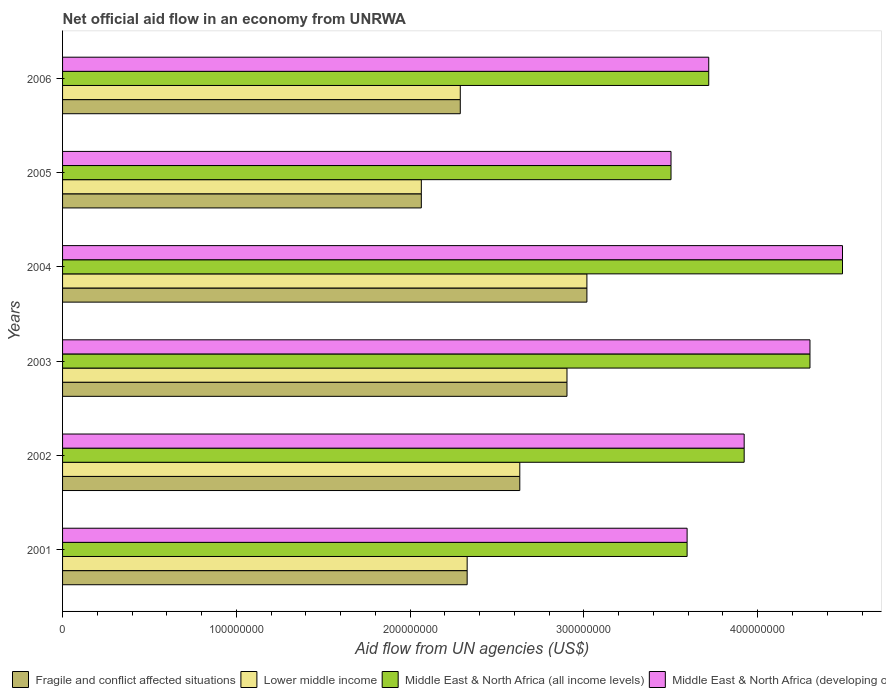How many different coloured bars are there?
Make the answer very short. 4. How many groups of bars are there?
Your answer should be very brief. 6. How many bars are there on the 5th tick from the bottom?
Keep it short and to the point. 4. In how many cases, is the number of bars for a given year not equal to the number of legend labels?
Make the answer very short. 0. What is the net official aid flow in Fragile and conflict affected situations in 2003?
Ensure brevity in your answer.  2.90e+08. Across all years, what is the maximum net official aid flow in Middle East & North Africa (developing only)?
Offer a terse response. 4.49e+08. Across all years, what is the minimum net official aid flow in Middle East & North Africa (all income levels)?
Make the answer very short. 3.50e+08. In which year was the net official aid flow in Middle East & North Africa (developing only) maximum?
Offer a very short reply. 2004. What is the total net official aid flow in Middle East & North Africa (all income levels) in the graph?
Offer a terse response. 2.35e+09. What is the difference between the net official aid flow in Fragile and conflict affected situations in 2004 and that in 2005?
Make the answer very short. 9.53e+07. What is the difference between the net official aid flow in Lower middle income in 2004 and the net official aid flow in Fragile and conflict affected situations in 2001?
Keep it short and to the point. 6.89e+07. What is the average net official aid flow in Middle East & North Africa (developing only) per year?
Your answer should be very brief. 3.92e+08. In the year 2006, what is the difference between the net official aid flow in Middle East & North Africa (developing only) and net official aid flow in Middle East & North Africa (all income levels)?
Offer a terse response. 0. What is the ratio of the net official aid flow in Middle East & North Africa (all income levels) in 2003 to that in 2005?
Your response must be concise. 1.23. What is the difference between the highest and the second highest net official aid flow in Fragile and conflict affected situations?
Give a very brief answer. 1.15e+07. What is the difference between the highest and the lowest net official aid flow in Middle East & North Africa (developing only)?
Provide a succinct answer. 9.87e+07. In how many years, is the net official aid flow in Middle East & North Africa (all income levels) greater than the average net official aid flow in Middle East & North Africa (all income levels) taken over all years?
Keep it short and to the point. 3. Is it the case that in every year, the sum of the net official aid flow in Middle East & North Africa (all income levels) and net official aid flow in Middle East & North Africa (developing only) is greater than the sum of net official aid flow in Fragile and conflict affected situations and net official aid flow in Lower middle income?
Your answer should be compact. No. What does the 1st bar from the top in 2006 represents?
Offer a terse response. Middle East & North Africa (developing only). What does the 2nd bar from the bottom in 2004 represents?
Provide a short and direct response. Lower middle income. Is it the case that in every year, the sum of the net official aid flow in Lower middle income and net official aid flow in Middle East & North Africa (all income levels) is greater than the net official aid flow in Middle East & North Africa (developing only)?
Offer a very short reply. Yes. Are all the bars in the graph horizontal?
Offer a very short reply. Yes. What is the difference between two consecutive major ticks on the X-axis?
Your response must be concise. 1.00e+08. Are the values on the major ticks of X-axis written in scientific E-notation?
Provide a succinct answer. No. Does the graph contain grids?
Offer a very short reply. No. How many legend labels are there?
Ensure brevity in your answer.  4. What is the title of the graph?
Provide a succinct answer. Net official aid flow in an economy from UNRWA. What is the label or title of the X-axis?
Make the answer very short. Aid flow from UN agencies (US$). What is the label or title of the Y-axis?
Your answer should be compact. Years. What is the Aid flow from UN agencies (US$) in Fragile and conflict affected situations in 2001?
Provide a succinct answer. 2.33e+08. What is the Aid flow from UN agencies (US$) of Lower middle income in 2001?
Offer a terse response. 2.33e+08. What is the Aid flow from UN agencies (US$) of Middle East & North Africa (all income levels) in 2001?
Keep it short and to the point. 3.59e+08. What is the Aid flow from UN agencies (US$) in Middle East & North Africa (developing only) in 2001?
Keep it short and to the point. 3.59e+08. What is the Aid flow from UN agencies (US$) in Fragile and conflict affected situations in 2002?
Offer a terse response. 2.63e+08. What is the Aid flow from UN agencies (US$) of Lower middle income in 2002?
Your response must be concise. 2.63e+08. What is the Aid flow from UN agencies (US$) of Middle East & North Africa (all income levels) in 2002?
Make the answer very short. 3.92e+08. What is the Aid flow from UN agencies (US$) of Middle East & North Africa (developing only) in 2002?
Give a very brief answer. 3.92e+08. What is the Aid flow from UN agencies (US$) of Fragile and conflict affected situations in 2003?
Provide a succinct answer. 2.90e+08. What is the Aid flow from UN agencies (US$) in Lower middle income in 2003?
Provide a succinct answer. 2.90e+08. What is the Aid flow from UN agencies (US$) of Middle East & North Africa (all income levels) in 2003?
Make the answer very short. 4.30e+08. What is the Aid flow from UN agencies (US$) of Middle East & North Africa (developing only) in 2003?
Make the answer very short. 4.30e+08. What is the Aid flow from UN agencies (US$) in Fragile and conflict affected situations in 2004?
Ensure brevity in your answer.  3.02e+08. What is the Aid flow from UN agencies (US$) in Lower middle income in 2004?
Offer a terse response. 3.02e+08. What is the Aid flow from UN agencies (US$) of Middle East & North Africa (all income levels) in 2004?
Your answer should be very brief. 4.49e+08. What is the Aid flow from UN agencies (US$) in Middle East & North Africa (developing only) in 2004?
Ensure brevity in your answer.  4.49e+08. What is the Aid flow from UN agencies (US$) in Fragile and conflict affected situations in 2005?
Your answer should be very brief. 2.06e+08. What is the Aid flow from UN agencies (US$) in Lower middle income in 2005?
Provide a short and direct response. 2.06e+08. What is the Aid flow from UN agencies (US$) in Middle East & North Africa (all income levels) in 2005?
Ensure brevity in your answer.  3.50e+08. What is the Aid flow from UN agencies (US$) in Middle East & North Africa (developing only) in 2005?
Your response must be concise. 3.50e+08. What is the Aid flow from UN agencies (US$) of Fragile and conflict affected situations in 2006?
Your answer should be compact. 2.29e+08. What is the Aid flow from UN agencies (US$) of Lower middle income in 2006?
Keep it short and to the point. 2.29e+08. What is the Aid flow from UN agencies (US$) in Middle East & North Africa (all income levels) in 2006?
Ensure brevity in your answer.  3.72e+08. What is the Aid flow from UN agencies (US$) in Middle East & North Africa (developing only) in 2006?
Provide a succinct answer. 3.72e+08. Across all years, what is the maximum Aid flow from UN agencies (US$) in Fragile and conflict affected situations?
Give a very brief answer. 3.02e+08. Across all years, what is the maximum Aid flow from UN agencies (US$) of Lower middle income?
Your response must be concise. 3.02e+08. Across all years, what is the maximum Aid flow from UN agencies (US$) of Middle East & North Africa (all income levels)?
Ensure brevity in your answer.  4.49e+08. Across all years, what is the maximum Aid flow from UN agencies (US$) of Middle East & North Africa (developing only)?
Ensure brevity in your answer.  4.49e+08. Across all years, what is the minimum Aid flow from UN agencies (US$) in Fragile and conflict affected situations?
Provide a short and direct response. 2.06e+08. Across all years, what is the minimum Aid flow from UN agencies (US$) in Lower middle income?
Your answer should be very brief. 2.06e+08. Across all years, what is the minimum Aid flow from UN agencies (US$) in Middle East & North Africa (all income levels)?
Keep it short and to the point. 3.50e+08. Across all years, what is the minimum Aid flow from UN agencies (US$) of Middle East & North Africa (developing only)?
Make the answer very short. 3.50e+08. What is the total Aid flow from UN agencies (US$) of Fragile and conflict affected situations in the graph?
Provide a succinct answer. 1.52e+09. What is the total Aid flow from UN agencies (US$) in Lower middle income in the graph?
Give a very brief answer. 1.52e+09. What is the total Aid flow from UN agencies (US$) in Middle East & North Africa (all income levels) in the graph?
Keep it short and to the point. 2.35e+09. What is the total Aid flow from UN agencies (US$) in Middle East & North Africa (developing only) in the graph?
Offer a very short reply. 2.35e+09. What is the difference between the Aid flow from UN agencies (US$) of Fragile and conflict affected situations in 2001 and that in 2002?
Your answer should be very brief. -3.03e+07. What is the difference between the Aid flow from UN agencies (US$) of Lower middle income in 2001 and that in 2002?
Make the answer very short. -3.03e+07. What is the difference between the Aid flow from UN agencies (US$) of Middle East & North Africa (all income levels) in 2001 and that in 2002?
Your response must be concise. -3.28e+07. What is the difference between the Aid flow from UN agencies (US$) in Middle East & North Africa (developing only) in 2001 and that in 2002?
Offer a very short reply. -3.28e+07. What is the difference between the Aid flow from UN agencies (US$) of Fragile and conflict affected situations in 2001 and that in 2003?
Provide a succinct answer. -5.74e+07. What is the difference between the Aid flow from UN agencies (US$) of Lower middle income in 2001 and that in 2003?
Offer a terse response. -5.74e+07. What is the difference between the Aid flow from UN agencies (US$) of Middle East & North Africa (all income levels) in 2001 and that in 2003?
Provide a short and direct response. -7.07e+07. What is the difference between the Aid flow from UN agencies (US$) in Middle East & North Africa (developing only) in 2001 and that in 2003?
Provide a succinct answer. -7.07e+07. What is the difference between the Aid flow from UN agencies (US$) of Fragile and conflict affected situations in 2001 and that in 2004?
Offer a very short reply. -6.89e+07. What is the difference between the Aid flow from UN agencies (US$) of Lower middle income in 2001 and that in 2004?
Ensure brevity in your answer.  -6.89e+07. What is the difference between the Aid flow from UN agencies (US$) of Middle East & North Africa (all income levels) in 2001 and that in 2004?
Make the answer very short. -8.94e+07. What is the difference between the Aid flow from UN agencies (US$) of Middle East & North Africa (developing only) in 2001 and that in 2004?
Your answer should be very brief. -8.94e+07. What is the difference between the Aid flow from UN agencies (US$) of Fragile and conflict affected situations in 2001 and that in 2005?
Provide a succinct answer. 2.64e+07. What is the difference between the Aid flow from UN agencies (US$) in Lower middle income in 2001 and that in 2005?
Make the answer very short. 2.64e+07. What is the difference between the Aid flow from UN agencies (US$) in Middle East & North Africa (all income levels) in 2001 and that in 2005?
Make the answer very short. 9.26e+06. What is the difference between the Aid flow from UN agencies (US$) of Middle East & North Africa (developing only) in 2001 and that in 2005?
Ensure brevity in your answer.  9.26e+06. What is the difference between the Aid flow from UN agencies (US$) of Fragile and conflict affected situations in 2001 and that in 2006?
Keep it short and to the point. 3.96e+06. What is the difference between the Aid flow from UN agencies (US$) of Lower middle income in 2001 and that in 2006?
Your response must be concise. 3.96e+06. What is the difference between the Aid flow from UN agencies (US$) in Middle East & North Africa (all income levels) in 2001 and that in 2006?
Your answer should be compact. -1.24e+07. What is the difference between the Aid flow from UN agencies (US$) of Middle East & North Africa (developing only) in 2001 and that in 2006?
Provide a short and direct response. -1.24e+07. What is the difference between the Aid flow from UN agencies (US$) of Fragile and conflict affected situations in 2002 and that in 2003?
Your answer should be very brief. -2.72e+07. What is the difference between the Aid flow from UN agencies (US$) of Lower middle income in 2002 and that in 2003?
Your answer should be compact. -2.72e+07. What is the difference between the Aid flow from UN agencies (US$) in Middle East & North Africa (all income levels) in 2002 and that in 2003?
Keep it short and to the point. -3.79e+07. What is the difference between the Aid flow from UN agencies (US$) in Middle East & North Africa (developing only) in 2002 and that in 2003?
Your answer should be very brief. -3.79e+07. What is the difference between the Aid flow from UN agencies (US$) in Fragile and conflict affected situations in 2002 and that in 2004?
Make the answer very short. -3.86e+07. What is the difference between the Aid flow from UN agencies (US$) in Lower middle income in 2002 and that in 2004?
Offer a terse response. -3.86e+07. What is the difference between the Aid flow from UN agencies (US$) in Middle East & North Africa (all income levels) in 2002 and that in 2004?
Give a very brief answer. -5.66e+07. What is the difference between the Aid flow from UN agencies (US$) of Middle East & North Africa (developing only) in 2002 and that in 2004?
Give a very brief answer. -5.66e+07. What is the difference between the Aid flow from UN agencies (US$) in Fragile and conflict affected situations in 2002 and that in 2005?
Your answer should be compact. 5.67e+07. What is the difference between the Aid flow from UN agencies (US$) in Lower middle income in 2002 and that in 2005?
Give a very brief answer. 5.67e+07. What is the difference between the Aid flow from UN agencies (US$) in Middle East & North Africa (all income levels) in 2002 and that in 2005?
Provide a short and direct response. 4.21e+07. What is the difference between the Aid flow from UN agencies (US$) in Middle East & North Africa (developing only) in 2002 and that in 2005?
Give a very brief answer. 4.21e+07. What is the difference between the Aid flow from UN agencies (US$) of Fragile and conflict affected situations in 2002 and that in 2006?
Offer a very short reply. 3.42e+07. What is the difference between the Aid flow from UN agencies (US$) of Lower middle income in 2002 and that in 2006?
Your response must be concise. 3.42e+07. What is the difference between the Aid flow from UN agencies (US$) of Middle East & North Africa (all income levels) in 2002 and that in 2006?
Your answer should be compact. 2.04e+07. What is the difference between the Aid flow from UN agencies (US$) in Middle East & North Africa (developing only) in 2002 and that in 2006?
Make the answer very short. 2.04e+07. What is the difference between the Aid flow from UN agencies (US$) of Fragile and conflict affected situations in 2003 and that in 2004?
Offer a very short reply. -1.15e+07. What is the difference between the Aid flow from UN agencies (US$) in Lower middle income in 2003 and that in 2004?
Make the answer very short. -1.15e+07. What is the difference between the Aid flow from UN agencies (US$) of Middle East & North Africa (all income levels) in 2003 and that in 2004?
Provide a short and direct response. -1.87e+07. What is the difference between the Aid flow from UN agencies (US$) of Middle East & North Africa (developing only) in 2003 and that in 2004?
Your answer should be very brief. -1.87e+07. What is the difference between the Aid flow from UN agencies (US$) in Fragile and conflict affected situations in 2003 and that in 2005?
Your response must be concise. 8.38e+07. What is the difference between the Aid flow from UN agencies (US$) of Lower middle income in 2003 and that in 2005?
Your answer should be compact. 8.38e+07. What is the difference between the Aid flow from UN agencies (US$) in Middle East & North Africa (all income levels) in 2003 and that in 2005?
Offer a very short reply. 8.00e+07. What is the difference between the Aid flow from UN agencies (US$) of Middle East & North Africa (developing only) in 2003 and that in 2005?
Your answer should be compact. 8.00e+07. What is the difference between the Aid flow from UN agencies (US$) in Fragile and conflict affected situations in 2003 and that in 2006?
Offer a very short reply. 6.14e+07. What is the difference between the Aid flow from UN agencies (US$) of Lower middle income in 2003 and that in 2006?
Your answer should be compact. 6.14e+07. What is the difference between the Aid flow from UN agencies (US$) of Middle East & North Africa (all income levels) in 2003 and that in 2006?
Offer a terse response. 5.82e+07. What is the difference between the Aid flow from UN agencies (US$) of Middle East & North Africa (developing only) in 2003 and that in 2006?
Ensure brevity in your answer.  5.82e+07. What is the difference between the Aid flow from UN agencies (US$) in Fragile and conflict affected situations in 2004 and that in 2005?
Your answer should be very brief. 9.53e+07. What is the difference between the Aid flow from UN agencies (US$) of Lower middle income in 2004 and that in 2005?
Offer a terse response. 9.53e+07. What is the difference between the Aid flow from UN agencies (US$) of Middle East & North Africa (all income levels) in 2004 and that in 2005?
Your answer should be very brief. 9.87e+07. What is the difference between the Aid flow from UN agencies (US$) of Middle East & North Africa (developing only) in 2004 and that in 2005?
Provide a short and direct response. 9.87e+07. What is the difference between the Aid flow from UN agencies (US$) of Fragile and conflict affected situations in 2004 and that in 2006?
Provide a succinct answer. 7.29e+07. What is the difference between the Aid flow from UN agencies (US$) of Lower middle income in 2004 and that in 2006?
Provide a short and direct response. 7.29e+07. What is the difference between the Aid flow from UN agencies (US$) of Middle East & North Africa (all income levels) in 2004 and that in 2006?
Ensure brevity in your answer.  7.70e+07. What is the difference between the Aid flow from UN agencies (US$) in Middle East & North Africa (developing only) in 2004 and that in 2006?
Your answer should be compact. 7.70e+07. What is the difference between the Aid flow from UN agencies (US$) in Fragile and conflict affected situations in 2005 and that in 2006?
Your answer should be very brief. -2.24e+07. What is the difference between the Aid flow from UN agencies (US$) in Lower middle income in 2005 and that in 2006?
Provide a short and direct response. -2.24e+07. What is the difference between the Aid flow from UN agencies (US$) of Middle East & North Africa (all income levels) in 2005 and that in 2006?
Ensure brevity in your answer.  -2.17e+07. What is the difference between the Aid flow from UN agencies (US$) of Middle East & North Africa (developing only) in 2005 and that in 2006?
Provide a short and direct response. -2.17e+07. What is the difference between the Aid flow from UN agencies (US$) of Fragile and conflict affected situations in 2001 and the Aid flow from UN agencies (US$) of Lower middle income in 2002?
Give a very brief answer. -3.03e+07. What is the difference between the Aid flow from UN agencies (US$) of Fragile and conflict affected situations in 2001 and the Aid flow from UN agencies (US$) of Middle East & North Africa (all income levels) in 2002?
Your answer should be compact. -1.59e+08. What is the difference between the Aid flow from UN agencies (US$) of Fragile and conflict affected situations in 2001 and the Aid flow from UN agencies (US$) of Middle East & North Africa (developing only) in 2002?
Give a very brief answer. -1.59e+08. What is the difference between the Aid flow from UN agencies (US$) in Lower middle income in 2001 and the Aid flow from UN agencies (US$) in Middle East & North Africa (all income levels) in 2002?
Offer a very short reply. -1.59e+08. What is the difference between the Aid flow from UN agencies (US$) in Lower middle income in 2001 and the Aid flow from UN agencies (US$) in Middle East & North Africa (developing only) in 2002?
Offer a terse response. -1.59e+08. What is the difference between the Aid flow from UN agencies (US$) of Middle East & North Africa (all income levels) in 2001 and the Aid flow from UN agencies (US$) of Middle East & North Africa (developing only) in 2002?
Provide a short and direct response. -3.28e+07. What is the difference between the Aid flow from UN agencies (US$) in Fragile and conflict affected situations in 2001 and the Aid flow from UN agencies (US$) in Lower middle income in 2003?
Provide a succinct answer. -5.74e+07. What is the difference between the Aid flow from UN agencies (US$) in Fragile and conflict affected situations in 2001 and the Aid flow from UN agencies (US$) in Middle East & North Africa (all income levels) in 2003?
Provide a succinct answer. -1.97e+08. What is the difference between the Aid flow from UN agencies (US$) in Fragile and conflict affected situations in 2001 and the Aid flow from UN agencies (US$) in Middle East & North Africa (developing only) in 2003?
Provide a succinct answer. -1.97e+08. What is the difference between the Aid flow from UN agencies (US$) of Lower middle income in 2001 and the Aid flow from UN agencies (US$) of Middle East & North Africa (all income levels) in 2003?
Your answer should be compact. -1.97e+08. What is the difference between the Aid flow from UN agencies (US$) of Lower middle income in 2001 and the Aid flow from UN agencies (US$) of Middle East & North Africa (developing only) in 2003?
Offer a terse response. -1.97e+08. What is the difference between the Aid flow from UN agencies (US$) in Middle East & North Africa (all income levels) in 2001 and the Aid flow from UN agencies (US$) in Middle East & North Africa (developing only) in 2003?
Give a very brief answer. -7.07e+07. What is the difference between the Aid flow from UN agencies (US$) in Fragile and conflict affected situations in 2001 and the Aid flow from UN agencies (US$) in Lower middle income in 2004?
Ensure brevity in your answer.  -6.89e+07. What is the difference between the Aid flow from UN agencies (US$) of Fragile and conflict affected situations in 2001 and the Aid flow from UN agencies (US$) of Middle East & North Africa (all income levels) in 2004?
Provide a succinct answer. -2.16e+08. What is the difference between the Aid flow from UN agencies (US$) of Fragile and conflict affected situations in 2001 and the Aid flow from UN agencies (US$) of Middle East & North Africa (developing only) in 2004?
Offer a very short reply. -2.16e+08. What is the difference between the Aid flow from UN agencies (US$) in Lower middle income in 2001 and the Aid flow from UN agencies (US$) in Middle East & North Africa (all income levels) in 2004?
Ensure brevity in your answer.  -2.16e+08. What is the difference between the Aid flow from UN agencies (US$) of Lower middle income in 2001 and the Aid flow from UN agencies (US$) of Middle East & North Africa (developing only) in 2004?
Ensure brevity in your answer.  -2.16e+08. What is the difference between the Aid flow from UN agencies (US$) in Middle East & North Africa (all income levels) in 2001 and the Aid flow from UN agencies (US$) in Middle East & North Africa (developing only) in 2004?
Your response must be concise. -8.94e+07. What is the difference between the Aid flow from UN agencies (US$) of Fragile and conflict affected situations in 2001 and the Aid flow from UN agencies (US$) of Lower middle income in 2005?
Make the answer very short. 2.64e+07. What is the difference between the Aid flow from UN agencies (US$) of Fragile and conflict affected situations in 2001 and the Aid flow from UN agencies (US$) of Middle East & North Africa (all income levels) in 2005?
Ensure brevity in your answer.  -1.17e+08. What is the difference between the Aid flow from UN agencies (US$) of Fragile and conflict affected situations in 2001 and the Aid flow from UN agencies (US$) of Middle East & North Africa (developing only) in 2005?
Provide a succinct answer. -1.17e+08. What is the difference between the Aid flow from UN agencies (US$) in Lower middle income in 2001 and the Aid flow from UN agencies (US$) in Middle East & North Africa (all income levels) in 2005?
Provide a short and direct response. -1.17e+08. What is the difference between the Aid flow from UN agencies (US$) in Lower middle income in 2001 and the Aid flow from UN agencies (US$) in Middle East & North Africa (developing only) in 2005?
Make the answer very short. -1.17e+08. What is the difference between the Aid flow from UN agencies (US$) of Middle East & North Africa (all income levels) in 2001 and the Aid flow from UN agencies (US$) of Middle East & North Africa (developing only) in 2005?
Provide a short and direct response. 9.26e+06. What is the difference between the Aid flow from UN agencies (US$) of Fragile and conflict affected situations in 2001 and the Aid flow from UN agencies (US$) of Lower middle income in 2006?
Provide a succinct answer. 3.96e+06. What is the difference between the Aid flow from UN agencies (US$) in Fragile and conflict affected situations in 2001 and the Aid flow from UN agencies (US$) in Middle East & North Africa (all income levels) in 2006?
Provide a succinct answer. -1.39e+08. What is the difference between the Aid flow from UN agencies (US$) in Fragile and conflict affected situations in 2001 and the Aid flow from UN agencies (US$) in Middle East & North Africa (developing only) in 2006?
Keep it short and to the point. -1.39e+08. What is the difference between the Aid flow from UN agencies (US$) of Lower middle income in 2001 and the Aid flow from UN agencies (US$) of Middle East & North Africa (all income levels) in 2006?
Provide a succinct answer. -1.39e+08. What is the difference between the Aid flow from UN agencies (US$) of Lower middle income in 2001 and the Aid flow from UN agencies (US$) of Middle East & North Africa (developing only) in 2006?
Ensure brevity in your answer.  -1.39e+08. What is the difference between the Aid flow from UN agencies (US$) of Middle East & North Africa (all income levels) in 2001 and the Aid flow from UN agencies (US$) of Middle East & North Africa (developing only) in 2006?
Make the answer very short. -1.24e+07. What is the difference between the Aid flow from UN agencies (US$) of Fragile and conflict affected situations in 2002 and the Aid flow from UN agencies (US$) of Lower middle income in 2003?
Make the answer very short. -2.72e+07. What is the difference between the Aid flow from UN agencies (US$) of Fragile and conflict affected situations in 2002 and the Aid flow from UN agencies (US$) of Middle East & North Africa (all income levels) in 2003?
Keep it short and to the point. -1.67e+08. What is the difference between the Aid flow from UN agencies (US$) in Fragile and conflict affected situations in 2002 and the Aid flow from UN agencies (US$) in Middle East & North Africa (developing only) in 2003?
Offer a terse response. -1.67e+08. What is the difference between the Aid flow from UN agencies (US$) in Lower middle income in 2002 and the Aid flow from UN agencies (US$) in Middle East & North Africa (all income levels) in 2003?
Provide a short and direct response. -1.67e+08. What is the difference between the Aid flow from UN agencies (US$) of Lower middle income in 2002 and the Aid flow from UN agencies (US$) of Middle East & North Africa (developing only) in 2003?
Make the answer very short. -1.67e+08. What is the difference between the Aid flow from UN agencies (US$) of Middle East & North Africa (all income levels) in 2002 and the Aid flow from UN agencies (US$) of Middle East & North Africa (developing only) in 2003?
Keep it short and to the point. -3.79e+07. What is the difference between the Aid flow from UN agencies (US$) in Fragile and conflict affected situations in 2002 and the Aid flow from UN agencies (US$) in Lower middle income in 2004?
Make the answer very short. -3.86e+07. What is the difference between the Aid flow from UN agencies (US$) in Fragile and conflict affected situations in 2002 and the Aid flow from UN agencies (US$) in Middle East & North Africa (all income levels) in 2004?
Offer a very short reply. -1.86e+08. What is the difference between the Aid flow from UN agencies (US$) of Fragile and conflict affected situations in 2002 and the Aid flow from UN agencies (US$) of Middle East & North Africa (developing only) in 2004?
Offer a terse response. -1.86e+08. What is the difference between the Aid flow from UN agencies (US$) of Lower middle income in 2002 and the Aid flow from UN agencies (US$) of Middle East & North Africa (all income levels) in 2004?
Ensure brevity in your answer.  -1.86e+08. What is the difference between the Aid flow from UN agencies (US$) of Lower middle income in 2002 and the Aid flow from UN agencies (US$) of Middle East & North Africa (developing only) in 2004?
Ensure brevity in your answer.  -1.86e+08. What is the difference between the Aid flow from UN agencies (US$) in Middle East & North Africa (all income levels) in 2002 and the Aid flow from UN agencies (US$) in Middle East & North Africa (developing only) in 2004?
Provide a short and direct response. -5.66e+07. What is the difference between the Aid flow from UN agencies (US$) in Fragile and conflict affected situations in 2002 and the Aid flow from UN agencies (US$) in Lower middle income in 2005?
Your answer should be very brief. 5.67e+07. What is the difference between the Aid flow from UN agencies (US$) in Fragile and conflict affected situations in 2002 and the Aid flow from UN agencies (US$) in Middle East & North Africa (all income levels) in 2005?
Your answer should be compact. -8.70e+07. What is the difference between the Aid flow from UN agencies (US$) in Fragile and conflict affected situations in 2002 and the Aid flow from UN agencies (US$) in Middle East & North Africa (developing only) in 2005?
Your response must be concise. -8.70e+07. What is the difference between the Aid flow from UN agencies (US$) of Lower middle income in 2002 and the Aid flow from UN agencies (US$) of Middle East & North Africa (all income levels) in 2005?
Make the answer very short. -8.70e+07. What is the difference between the Aid flow from UN agencies (US$) in Lower middle income in 2002 and the Aid flow from UN agencies (US$) in Middle East & North Africa (developing only) in 2005?
Make the answer very short. -8.70e+07. What is the difference between the Aid flow from UN agencies (US$) of Middle East & North Africa (all income levels) in 2002 and the Aid flow from UN agencies (US$) of Middle East & North Africa (developing only) in 2005?
Keep it short and to the point. 4.21e+07. What is the difference between the Aid flow from UN agencies (US$) of Fragile and conflict affected situations in 2002 and the Aid flow from UN agencies (US$) of Lower middle income in 2006?
Provide a succinct answer. 3.42e+07. What is the difference between the Aid flow from UN agencies (US$) of Fragile and conflict affected situations in 2002 and the Aid flow from UN agencies (US$) of Middle East & North Africa (all income levels) in 2006?
Ensure brevity in your answer.  -1.09e+08. What is the difference between the Aid flow from UN agencies (US$) of Fragile and conflict affected situations in 2002 and the Aid flow from UN agencies (US$) of Middle East & North Africa (developing only) in 2006?
Keep it short and to the point. -1.09e+08. What is the difference between the Aid flow from UN agencies (US$) in Lower middle income in 2002 and the Aid flow from UN agencies (US$) in Middle East & North Africa (all income levels) in 2006?
Offer a very short reply. -1.09e+08. What is the difference between the Aid flow from UN agencies (US$) of Lower middle income in 2002 and the Aid flow from UN agencies (US$) of Middle East & North Africa (developing only) in 2006?
Provide a short and direct response. -1.09e+08. What is the difference between the Aid flow from UN agencies (US$) of Middle East & North Africa (all income levels) in 2002 and the Aid flow from UN agencies (US$) of Middle East & North Africa (developing only) in 2006?
Ensure brevity in your answer.  2.04e+07. What is the difference between the Aid flow from UN agencies (US$) of Fragile and conflict affected situations in 2003 and the Aid flow from UN agencies (US$) of Lower middle income in 2004?
Ensure brevity in your answer.  -1.15e+07. What is the difference between the Aid flow from UN agencies (US$) in Fragile and conflict affected situations in 2003 and the Aid flow from UN agencies (US$) in Middle East & North Africa (all income levels) in 2004?
Give a very brief answer. -1.59e+08. What is the difference between the Aid flow from UN agencies (US$) of Fragile and conflict affected situations in 2003 and the Aid flow from UN agencies (US$) of Middle East & North Africa (developing only) in 2004?
Your answer should be compact. -1.59e+08. What is the difference between the Aid flow from UN agencies (US$) of Lower middle income in 2003 and the Aid flow from UN agencies (US$) of Middle East & North Africa (all income levels) in 2004?
Provide a succinct answer. -1.59e+08. What is the difference between the Aid flow from UN agencies (US$) of Lower middle income in 2003 and the Aid flow from UN agencies (US$) of Middle East & North Africa (developing only) in 2004?
Make the answer very short. -1.59e+08. What is the difference between the Aid flow from UN agencies (US$) of Middle East & North Africa (all income levels) in 2003 and the Aid flow from UN agencies (US$) of Middle East & North Africa (developing only) in 2004?
Your answer should be very brief. -1.87e+07. What is the difference between the Aid flow from UN agencies (US$) of Fragile and conflict affected situations in 2003 and the Aid flow from UN agencies (US$) of Lower middle income in 2005?
Your response must be concise. 8.38e+07. What is the difference between the Aid flow from UN agencies (US$) of Fragile and conflict affected situations in 2003 and the Aid flow from UN agencies (US$) of Middle East & North Africa (all income levels) in 2005?
Give a very brief answer. -5.99e+07. What is the difference between the Aid flow from UN agencies (US$) in Fragile and conflict affected situations in 2003 and the Aid flow from UN agencies (US$) in Middle East & North Africa (developing only) in 2005?
Your answer should be very brief. -5.99e+07. What is the difference between the Aid flow from UN agencies (US$) in Lower middle income in 2003 and the Aid flow from UN agencies (US$) in Middle East & North Africa (all income levels) in 2005?
Offer a very short reply. -5.99e+07. What is the difference between the Aid flow from UN agencies (US$) of Lower middle income in 2003 and the Aid flow from UN agencies (US$) of Middle East & North Africa (developing only) in 2005?
Make the answer very short. -5.99e+07. What is the difference between the Aid flow from UN agencies (US$) in Middle East & North Africa (all income levels) in 2003 and the Aid flow from UN agencies (US$) in Middle East & North Africa (developing only) in 2005?
Keep it short and to the point. 8.00e+07. What is the difference between the Aid flow from UN agencies (US$) in Fragile and conflict affected situations in 2003 and the Aid flow from UN agencies (US$) in Lower middle income in 2006?
Provide a succinct answer. 6.14e+07. What is the difference between the Aid flow from UN agencies (US$) of Fragile and conflict affected situations in 2003 and the Aid flow from UN agencies (US$) of Middle East & North Africa (all income levels) in 2006?
Your response must be concise. -8.16e+07. What is the difference between the Aid flow from UN agencies (US$) in Fragile and conflict affected situations in 2003 and the Aid flow from UN agencies (US$) in Middle East & North Africa (developing only) in 2006?
Keep it short and to the point. -8.16e+07. What is the difference between the Aid flow from UN agencies (US$) in Lower middle income in 2003 and the Aid flow from UN agencies (US$) in Middle East & North Africa (all income levels) in 2006?
Your response must be concise. -8.16e+07. What is the difference between the Aid flow from UN agencies (US$) of Lower middle income in 2003 and the Aid flow from UN agencies (US$) of Middle East & North Africa (developing only) in 2006?
Provide a succinct answer. -8.16e+07. What is the difference between the Aid flow from UN agencies (US$) in Middle East & North Africa (all income levels) in 2003 and the Aid flow from UN agencies (US$) in Middle East & North Africa (developing only) in 2006?
Your answer should be very brief. 5.82e+07. What is the difference between the Aid flow from UN agencies (US$) in Fragile and conflict affected situations in 2004 and the Aid flow from UN agencies (US$) in Lower middle income in 2005?
Give a very brief answer. 9.53e+07. What is the difference between the Aid flow from UN agencies (US$) of Fragile and conflict affected situations in 2004 and the Aid flow from UN agencies (US$) of Middle East & North Africa (all income levels) in 2005?
Your response must be concise. -4.84e+07. What is the difference between the Aid flow from UN agencies (US$) in Fragile and conflict affected situations in 2004 and the Aid flow from UN agencies (US$) in Middle East & North Africa (developing only) in 2005?
Make the answer very short. -4.84e+07. What is the difference between the Aid flow from UN agencies (US$) in Lower middle income in 2004 and the Aid flow from UN agencies (US$) in Middle East & North Africa (all income levels) in 2005?
Provide a short and direct response. -4.84e+07. What is the difference between the Aid flow from UN agencies (US$) in Lower middle income in 2004 and the Aid flow from UN agencies (US$) in Middle East & North Africa (developing only) in 2005?
Offer a very short reply. -4.84e+07. What is the difference between the Aid flow from UN agencies (US$) in Middle East & North Africa (all income levels) in 2004 and the Aid flow from UN agencies (US$) in Middle East & North Africa (developing only) in 2005?
Offer a very short reply. 9.87e+07. What is the difference between the Aid flow from UN agencies (US$) in Fragile and conflict affected situations in 2004 and the Aid flow from UN agencies (US$) in Lower middle income in 2006?
Give a very brief answer. 7.29e+07. What is the difference between the Aid flow from UN agencies (US$) in Fragile and conflict affected situations in 2004 and the Aid flow from UN agencies (US$) in Middle East & North Africa (all income levels) in 2006?
Give a very brief answer. -7.01e+07. What is the difference between the Aid flow from UN agencies (US$) of Fragile and conflict affected situations in 2004 and the Aid flow from UN agencies (US$) of Middle East & North Africa (developing only) in 2006?
Offer a very short reply. -7.01e+07. What is the difference between the Aid flow from UN agencies (US$) of Lower middle income in 2004 and the Aid flow from UN agencies (US$) of Middle East & North Africa (all income levels) in 2006?
Provide a short and direct response. -7.01e+07. What is the difference between the Aid flow from UN agencies (US$) in Lower middle income in 2004 and the Aid flow from UN agencies (US$) in Middle East & North Africa (developing only) in 2006?
Ensure brevity in your answer.  -7.01e+07. What is the difference between the Aid flow from UN agencies (US$) in Middle East & North Africa (all income levels) in 2004 and the Aid flow from UN agencies (US$) in Middle East & North Africa (developing only) in 2006?
Keep it short and to the point. 7.70e+07. What is the difference between the Aid flow from UN agencies (US$) in Fragile and conflict affected situations in 2005 and the Aid flow from UN agencies (US$) in Lower middle income in 2006?
Give a very brief answer. -2.24e+07. What is the difference between the Aid flow from UN agencies (US$) in Fragile and conflict affected situations in 2005 and the Aid flow from UN agencies (US$) in Middle East & North Africa (all income levels) in 2006?
Your response must be concise. -1.65e+08. What is the difference between the Aid flow from UN agencies (US$) of Fragile and conflict affected situations in 2005 and the Aid flow from UN agencies (US$) of Middle East & North Africa (developing only) in 2006?
Make the answer very short. -1.65e+08. What is the difference between the Aid flow from UN agencies (US$) in Lower middle income in 2005 and the Aid flow from UN agencies (US$) in Middle East & North Africa (all income levels) in 2006?
Ensure brevity in your answer.  -1.65e+08. What is the difference between the Aid flow from UN agencies (US$) of Lower middle income in 2005 and the Aid flow from UN agencies (US$) of Middle East & North Africa (developing only) in 2006?
Ensure brevity in your answer.  -1.65e+08. What is the difference between the Aid flow from UN agencies (US$) of Middle East & North Africa (all income levels) in 2005 and the Aid flow from UN agencies (US$) of Middle East & North Africa (developing only) in 2006?
Give a very brief answer. -2.17e+07. What is the average Aid flow from UN agencies (US$) in Fragile and conflict affected situations per year?
Keep it short and to the point. 2.54e+08. What is the average Aid flow from UN agencies (US$) of Lower middle income per year?
Provide a succinct answer. 2.54e+08. What is the average Aid flow from UN agencies (US$) of Middle East & North Africa (all income levels) per year?
Your answer should be compact. 3.92e+08. What is the average Aid flow from UN agencies (US$) in Middle East & North Africa (developing only) per year?
Provide a succinct answer. 3.92e+08. In the year 2001, what is the difference between the Aid flow from UN agencies (US$) in Fragile and conflict affected situations and Aid flow from UN agencies (US$) in Lower middle income?
Provide a short and direct response. 0. In the year 2001, what is the difference between the Aid flow from UN agencies (US$) in Fragile and conflict affected situations and Aid flow from UN agencies (US$) in Middle East & North Africa (all income levels)?
Ensure brevity in your answer.  -1.27e+08. In the year 2001, what is the difference between the Aid flow from UN agencies (US$) in Fragile and conflict affected situations and Aid flow from UN agencies (US$) in Middle East & North Africa (developing only)?
Offer a very short reply. -1.27e+08. In the year 2001, what is the difference between the Aid flow from UN agencies (US$) in Lower middle income and Aid flow from UN agencies (US$) in Middle East & North Africa (all income levels)?
Offer a terse response. -1.27e+08. In the year 2001, what is the difference between the Aid flow from UN agencies (US$) of Lower middle income and Aid flow from UN agencies (US$) of Middle East & North Africa (developing only)?
Your response must be concise. -1.27e+08. In the year 2002, what is the difference between the Aid flow from UN agencies (US$) of Fragile and conflict affected situations and Aid flow from UN agencies (US$) of Lower middle income?
Ensure brevity in your answer.  0. In the year 2002, what is the difference between the Aid flow from UN agencies (US$) of Fragile and conflict affected situations and Aid flow from UN agencies (US$) of Middle East & North Africa (all income levels)?
Make the answer very short. -1.29e+08. In the year 2002, what is the difference between the Aid flow from UN agencies (US$) of Fragile and conflict affected situations and Aid flow from UN agencies (US$) of Middle East & North Africa (developing only)?
Your answer should be compact. -1.29e+08. In the year 2002, what is the difference between the Aid flow from UN agencies (US$) of Lower middle income and Aid flow from UN agencies (US$) of Middle East & North Africa (all income levels)?
Your answer should be very brief. -1.29e+08. In the year 2002, what is the difference between the Aid flow from UN agencies (US$) in Lower middle income and Aid flow from UN agencies (US$) in Middle East & North Africa (developing only)?
Provide a short and direct response. -1.29e+08. In the year 2002, what is the difference between the Aid flow from UN agencies (US$) of Middle East & North Africa (all income levels) and Aid flow from UN agencies (US$) of Middle East & North Africa (developing only)?
Provide a succinct answer. 0. In the year 2003, what is the difference between the Aid flow from UN agencies (US$) of Fragile and conflict affected situations and Aid flow from UN agencies (US$) of Middle East & North Africa (all income levels)?
Your answer should be very brief. -1.40e+08. In the year 2003, what is the difference between the Aid flow from UN agencies (US$) of Fragile and conflict affected situations and Aid flow from UN agencies (US$) of Middle East & North Africa (developing only)?
Your response must be concise. -1.40e+08. In the year 2003, what is the difference between the Aid flow from UN agencies (US$) of Lower middle income and Aid flow from UN agencies (US$) of Middle East & North Africa (all income levels)?
Your answer should be very brief. -1.40e+08. In the year 2003, what is the difference between the Aid flow from UN agencies (US$) of Lower middle income and Aid flow from UN agencies (US$) of Middle East & North Africa (developing only)?
Make the answer very short. -1.40e+08. In the year 2004, what is the difference between the Aid flow from UN agencies (US$) in Fragile and conflict affected situations and Aid flow from UN agencies (US$) in Lower middle income?
Make the answer very short. 0. In the year 2004, what is the difference between the Aid flow from UN agencies (US$) of Fragile and conflict affected situations and Aid flow from UN agencies (US$) of Middle East & North Africa (all income levels)?
Provide a succinct answer. -1.47e+08. In the year 2004, what is the difference between the Aid flow from UN agencies (US$) in Fragile and conflict affected situations and Aid flow from UN agencies (US$) in Middle East & North Africa (developing only)?
Provide a succinct answer. -1.47e+08. In the year 2004, what is the difference between the Aid flow from UN agencies (US$) of Lower middle income and Aid flow from UN agencies (US$) of Middle East & North Africa (all income levels)?
Your answer should be compact. -1.47e+08. In the year 2004, what is the difference between the Aid flow from UN agencies (US$) in Lower middle income and Aid flow from UN agencies (US$) in Middle East & North Africa (developing only)?
Your answer should be compact. -1.47e+08. In the year 2005, what is the difference between the Aid flow from UN agencies (US$) of Fragile and conflict affected situations and Aid flow from UN agencies (US$) of Middle East & North Africa (all income levels)?
Your answer should be compact. -1.44e+08. In the year 2005, what is the difference between the Aid flow from UN agencies (US$) of Fragile and conflict affected situations and Aid flow from UN agencies (US$) of Middle East & North Africa (developing only)?
Keep it short and to the point. -1.44e+08. In the year 2005, what is the difference between the Aid flow from UN agencies (US$) in Lower middle income and Aid flow from UN agencies (US$) in Middle East & North Africa (all income levels)?
Make the answer very short. -1.44e+08. In the year 2005, what is the difference between the Aid flow from UN agencies (US$) in Lower middle income and Aid flow from UN agencies (US$) in Middle East & North Africa (developing only)?
Give a very brief answer. -1.44e+08. In the year 2005, what is the difference between the Aid flow from UN agencies (US$) of Middle East & North Africa (all income levels) and Aid flow from UN agencies (US$) of Middle East & North Africa (developing only)?
Your answer should be compact. 0. In the year 2006, what is the difference between the Aid flow from UN agencies (US$) in Fragile and conflict affected situations and Aid flow from UN agencies (US$) in Lower middle income?
Keep it short and to the point. 0. In the year 2006, what is the difference between the Aid flow from UN agencies (US$) in Fragile and conflict affected situations and Aid flow from UN agencies (US$) in Middle East & North Africa (all income levels)?
Your answer should be very brief. -1.43e+08. In the year 2006, what is the difference between the Aid flow from UN agencies (US$) in Fragile and conflict affected situations and Aid flow from UN agencies (US$) in Middle East & North Africa (developing only)?
Your answer should be very brief. -1.43e+08. In the year 2006, what is the difference between the Aid flow from UN agencies (US$) in Lower middle income and Aid flow from UN agencies (US$) in Middle East & North Africa (all income levels)?
Provide a succinct answer. -1.43e+08. In the year 2006, what is the difference between the Aid flow from UN agencies (US$) in Lower middle income and Aid flow from UN agencies (US$) in Middle East & North Africa (developing only)?
Make the answer very short. -1.43e+08. What is the ratio of the Aid flow from UN agencies (US$) of Fragile and conflict affected situations in 2001 to that in 2002?
Keep it short and to the point. 0.88. What is the ratio of the Aid flow from UN agencies (US$) in Lower middle income in 2001 to that in 2002?
Give a very brief answer. 0.88. What is the ratio of the Aid flow from UN agencies (US$) in Middle East & North Africa (all income levels) in 2001 to that in 2002?
Make the answer very short. 0.92. What is the ratio of the Aid flow from UN agencies (US$) in Middle East & North Africa (developing only) in 2001 to that in 2002?
Give a very brief answer. 0.92. What is the ratio of the Aid flow from UN agencies (US$) of Fragile and conflict affected situations in 2001 to that in 2003?
Give a very brief answer. 0.8. What is the ratio of the Aid flow from UN agencies (US$) in Lower middle income in 2001 to that in 2003?
Give a very brief answer. 0.8. What is the ratio of the Aid flow from UN agencies (US$) in Middle East & North Africa (all income levels) in 2001 to that in 2003?
Offer a very short reply. 0.84. What is the ratio of the Aid flow from UN agencies (US$) of Middle East & North Africa (developing only) in 2001 to that in 2003?
Ensure brevity in your answer.  0.84. What is the ratio of the Aid flow from UN agencies (US$) of Fragile and conflict affected situations in 2001 to that in 2004?
Make the answer very short. 0.77. What is the ratio of the Aid flow from UN agencies (US$) of Lower middle income in 2001 to that in 2004?
Offer a terse response. 0.77. What is the ratio of the Aid flow from UN agencies (US$) in Middle East & North Africa (all income levels) in 2001 to that in 2004?
Your response must be concise. 0.8. What is the ratio of the Aid flow from UN agencies (US$) in Middle East & North Africa (developing only) in 2001 to that in 2004?
Provide a short and direct response. 0.8. What is the ratio of the Aid flow from UN agencies (US$) of Fragile and conflict affected situations in 2001 to that in 2005?
Your response must be concise. 1.13. What is the ratio of the Aid flow from UN agencies (US$) of Lower middle income in 2001 to that in 2005?
Your answer should be very brief. 1.13. What is the ratio of the Aid flow from UN agencies (US$) in Middle East & North Africa (all income levels) in 2001 to that in 2005?
Provide a short and direct response. 1.03. What is the ratio of the Aid flow from UN agencies (US$) of Middle East & North Africa (developing only) in 2001 to that in 2005?
Keep it short and to the point. 1.03. What is the ratio of the Aid flow from UN agencies (US$) of Fragile and conflict affected situations in 2001 to that in 2006?
Ensure brevity in your answer.  1.02. What is the ratio of the Aid flow from UN agencies (US$) of Lower middle income in 2001 to that in 2006?
Your response must be concise. 1.02. What is the ratio of the Aid flow from UN agencies (US$) in Middle East & North Africa (all income levels) in 2001 to that in 2006?
Keep it short and to the point. 0.97. What is the ratio of the Aid flow from UN agencies (US$) of Middle East & North Africa (developing only) in 2001 to that in 2006?
Provide a succinct answer. 0.97. What is the ratio of the Aid flow from UN agencies (US$) in Fragile and conflict affected situations in 2002 to that in 2003?
Keep it short and to the point. 0.91. What is the ratio of the Aid flow from UN agencies (US$) of Lower middle income in 2002 to that in 2003?
Give a very brief answer. 0.91. What is the ratio of the Aid flow from UN agencies (US$) in Middle East & North Africa (all income levels) in 2002 to that in 2003?
Your answer should be compact. 0.91. What is the ratio of the Aid flow from UN agencies (US$) in Middle East & North Africa (developing only) in 2002 to that in 2003?
Your answer should be very brief. 0.91. What is the ratio of the Aid flow from UN agencies (US$) of Fragile and conflict affected situations in 2002 to that in 2004?
Your answer should be compact. 0.87. What is the ratio of the Aid flow from UN agencies (US$) in Lower middle income in 2002 to that in 2004?
Provide a succinct answer. 0.87. What is the ratio of the Aid flow from UN agencies (US$) of Middle East & North Africa (all income levels) in 2002 to that in 2004?
Your response must be concise. 0.87. What is the ratio of the Aid flow from UN agencies (US$) in Middle East & North Africa (developing only) in 2002 to that in 2004?
Give a very brief answer. 0.87. What is the ratio of the Aid flow from UN agencies (US$) of Fragile and conflict affected situations in 2002 to that in 2005?
Give a very brief answer. 1.27. What is the ratio of the Aid flow from UN agencies (US$) of Lower middle income in 2002 to that in 2005?
Your answer should be very brief. 1.27. What is the ratio of the Aid flow from UN agencies (US$) of Middle East & North Africa (all income levels) in 2002 to that in 2005?
Offer a very short reply. 1.12. What is the ratio of the Aid flow from UN agencies (US$) of Middle East & North Africa (developing only) in 2002 to that in 2005?
Provide a short and direct response. 1.12. What is the ratio of the Aid flow from UN agencies (US$) in Fragile and conflict affected situations in 2002 to that in 2006?
Offer a very short reply. 1.15. What is the ratio of the Aid flow from UN agencies (US$) of Lower middle income in 2002 to that in 2006?
Your answer should be compact. 1.15. What is the ratio of the Aid flow from UN agencies (US$) of Middle East & North Africa (all income levels) in 2002 to that in 2006?
Offer a very short reply. 1.05. What is the ratio of the Aid flow from UN agencies (US$) in Middle East & North Africa (developing only) in 2002 to that in 2006?
Give a very brief answer. 1.05. What is the ratio of the Aid flow from UN agencies (US$) in Lower middle income in 2003 to that in 2004?
Your answer should be compact. 0.96. What is the ratio of the Aid flow from UN agencies (US$) of Middle East & North Africa (developing only) in 2003 to that in 2004?
Your response must be concise. 0.96. What is the ratio of the Aid flow from UN agencies (US$) of Fragile and conflict affected situations in 2003 to that in 2005?
Provide a short and direct response. 1.41. What is the ratio of the Aid flow from UN agencies (US$) of Lower middle income in 2003 to that in 2005?
Offer a terse response. 1.41. What is the ratio of the Aid flow from UN agencies (US$) in Middle East & North Africa (all income levels) in 2003 to that in 2005?
Your response must be concise. 1.23. What is the ratio of the Aid flow from UN agencies (US$) of Middle East & North Africa (developing only) in 2003 to that in 2005?
Keep it short and to the point. 1.23. What is the ratio of the Aid flow from UN agencies (US$) in Fragile and conflict affected situations in 2003 to that in 2006?
Ensure brevity in your answer.  1.27. What is the ratio of the Aid flow from UN agencies (US$) in Lower middle income in 2003 to that in 2006?
Give a very brief answer. 1.27. What is the ratio of the Aid flow from UN agencies (US$) in Middle East & North Africa (all income levels) in 2003 to that in 2006?
Provide a short and direct response. 1.16. What is the ratio of the Aid flow from UN agencies (US$) in Middle East & North Africa (developing only) in 2003 to that in 2006?
Give a very brief answer. 1.16. What is the ratio of the Aid flow from UN agencies (US$) in Fragile and conflict affected situations in 2004 to that in 2005?
Provide a succinct answer. 1.46. What is the ratio of the Aid flow from UN agencies (US$) in Lower middle income in 2004 to that in 2005?
Ensure brevity in your answer.  1.46. What is the ratio of the Aid flow from UN agencies (US$) in Middle East & North Africa (all income levels) in 2004 to that in 2005?
Offer a very short reply. 1.28. What is the ratio of the Aid flow from UN agencies (US$) in Middle East & North Africa (developing only) in 2004 to that in 2005?
Offer a very short reply. 1.28. What is the ratio of the Aid flow from UN agencies (US$) in Fragile and conflict affected situations in 2004 to that in 2006?
Offer a terse response. 1.32. What is the ratio of the Aid flow from UN agencies (US$) of Lower middle income in 2004 to that in 2006?
Make the answer very short. 1.32. What is the ratio of the Aid flow from UN agencies (US$) of Middle East & North Africa (all income levels) in 2004 to that in 2006?
Give a very brief answer. 1.21. What is the ratio of the Aid flow from UN agencies (US$) of Middle East & North Africa (developing only) in 2004 to that in 2006?
Make the answer very short. 1.21. What is the ratio of the Aid flow from UN agencies (US$) of Fragile and conflict affected situations in 2005 to that in 2006?
Make the answer very short. 0.9. What is the ratio of the Aid flow from UN agencies (US$) of Lower middle income in 2005 to that in 2006?
Offer a very short reply. 0.9. What is the ratio of the Aid flow from UN agencies (US$) in Middle East & North Africa (all income levels) in 2005 to that in 2006?
Ensure brevity in your answer.  0.94. What is the ratio of the Aid flow from UN agencies (US$) of Middle East & North Africa (developing only) in 2005 to that in 2006?
Offer a very short reply. 0.94. What is the difference between the highest and the second highest Aid flow from UN agencies (US$) of Fragile and conflict affected situations?
Give a very brief answer. 1.15e+07. What is the difference between the highest and the second highest Aid flow from UN agencies (US$) of Lower middle income?
Keep it short and to the point. 1.15e+07. What is the difference between the highest and the second highest Aid flow from UN agencies (US$) of Middle East & North Africa (all income levels)?
Provide a succinct answer. 1.87e+07. What is the difference between the highest and the second highest Aid flow from UN agencies (US$) of Middle East & North Africa (developing only)?
Provide a short and direct response. 1.87e+07. What is the difference between the highest and the lowest Aid flow from UN agencies (US$) of Fragile and conflict affected situations?
Your answer should be very brief. 9.53e+07. What is the difference between the highest and the lowest Aid flow from UN agencies (US$) of Lower middle income?
Offer a very short reply. 9.53e+07. What is the difference between the highest and the lowest Aid flow from UN agencies (US$) in Middle East & North Africa (all income levels)?
Ensure brevity in your answer.  9.87e+07. What is the difference between the highest and the lowest Aid flow from UN agencies (US$) in Middle East & North Africa (developing only)?
Make the answer very short. 9.87e+07. 